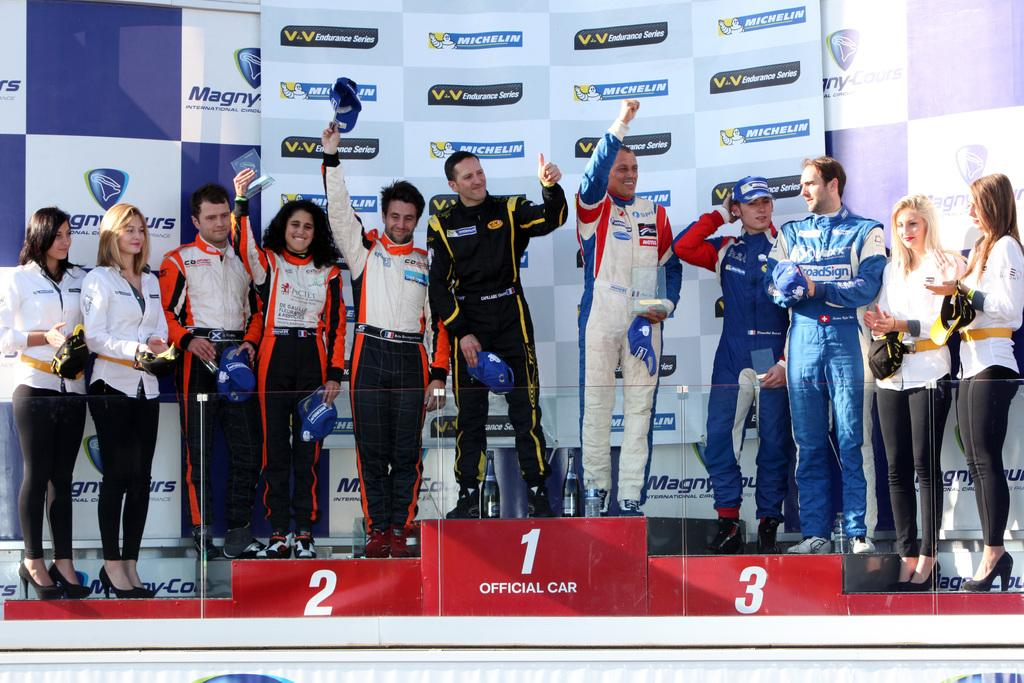Provide a one-sentence caption for the provided image. Racecar drivers win race sponsored by Michelin and Valvoline. 